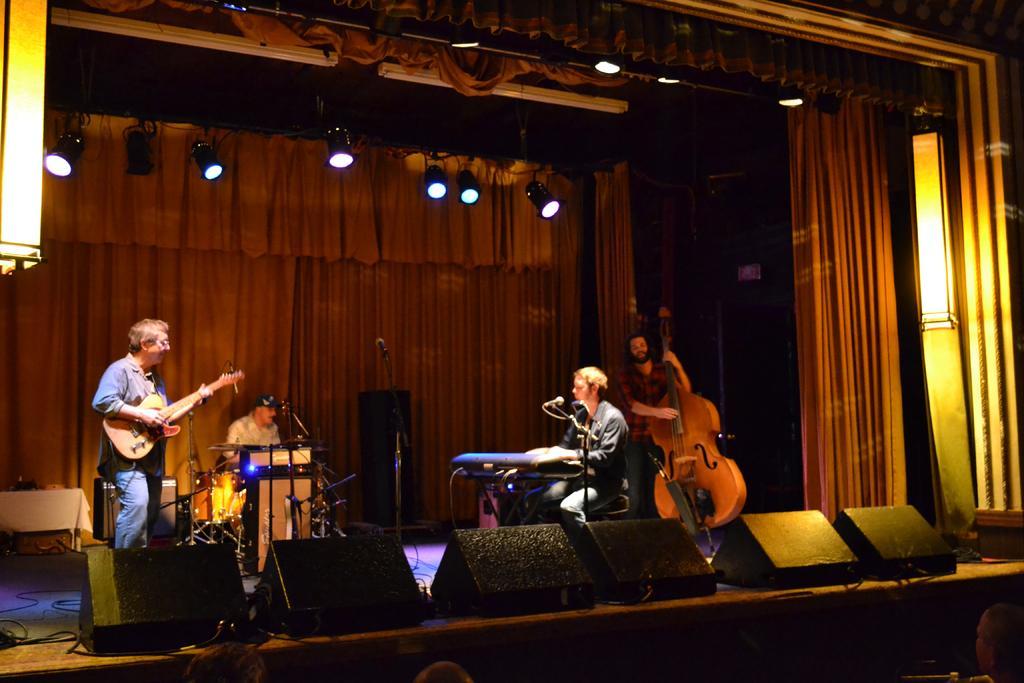Could you give a brief overview of what you see in this image? As we can see in the image there are lights, curtains, four people on stage. The man on the left and right side is holding guitars and these two people are sitting on chairs. 